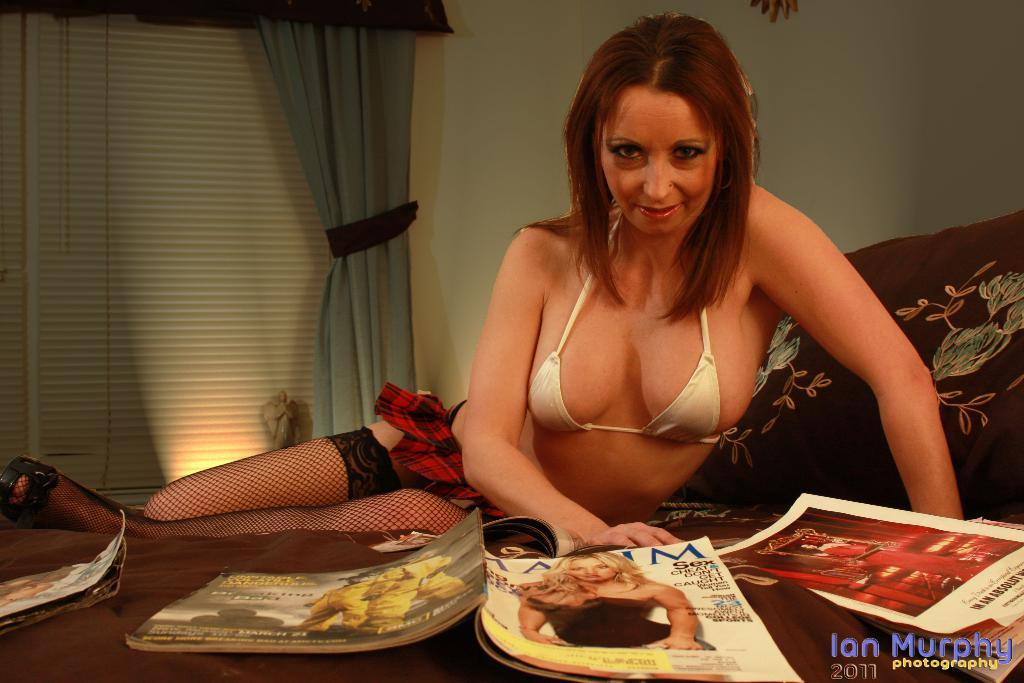Who or what is present in the image? There is a person in the image. What is the person interacting with or near in the image? There are magazines on a brown color surface in front of the person. What can be seen in the background of the image? There is a wall, a window, a curtain associated with the window, and a light in the background of the image. What does the queen say about the person in the image? There is no queen present in the image, so it is not possible to answer that question. 